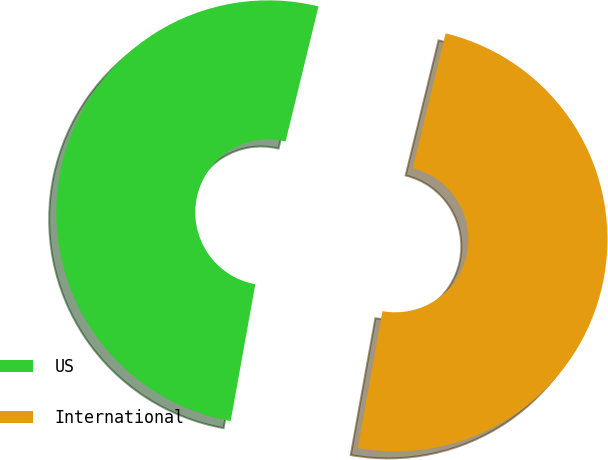Convert chart. <chart><loc_0><loc_0><loc_500><loc_500><pie_chart><fcel>US<fcel>International<nl><fcel>50.97%<fcel>49.03%<nl></chart> 